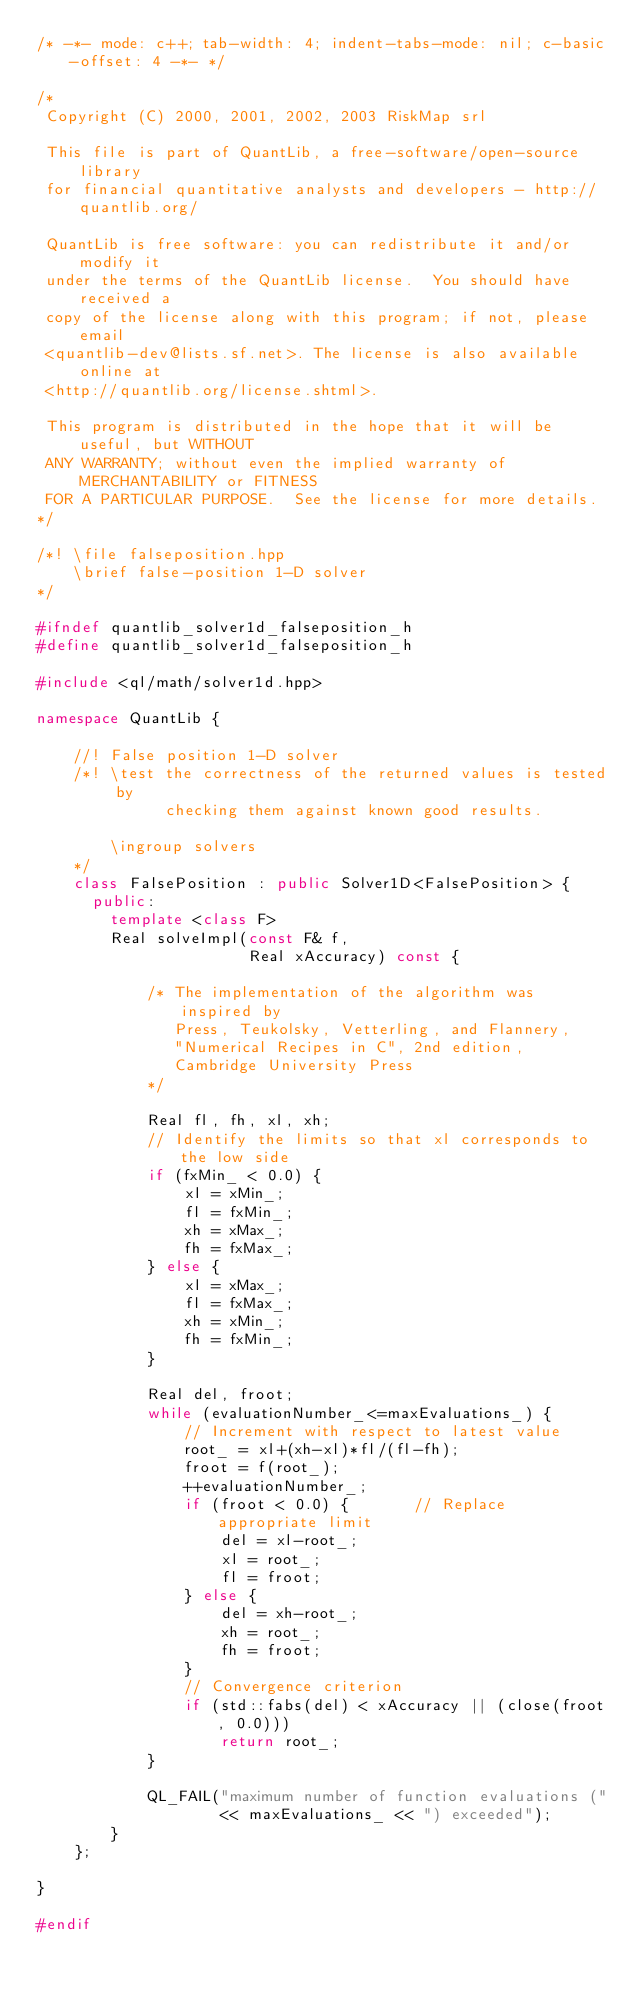<code> <loc_0><loc_0><loc_500><loc_500><_C++_>/* -*- mode: c++; tab-width: 4; indent-tabs-mode: nil; c-basic-offset: 4 -*- */

/*
 Copyright (C) 2000, 2001, 2002, 2003 RiskMap srl

 This file is part of QuantLib, a free-software/open-source library
 for financial quantitative analysts and developers - http://quantlib.org/

 QuantLib is free software: you can redistribute it and/or modify it
 under the terms of the QuantLib license.  You should have received a
 copy of the license along with this program; if not, please email
 <quantlib-dev@lists.sf.net>. The license is also available online at
 <http://quantlib.org/license.shtml>.

 This program is distributed in the hope that it will be useful, but WITHOUT
 ANY WARRANTY; without even the implied warranty of MERCHANTABILITY or FITNESS
 FOR A PARTICULAR PURPOSE.  See the license for more details.
*/

/*! \file falseposition.hpp
    \brief false-position 1-D solver
*/

#ifndef quantlib_solver1d_falseposition_h
#define quantlib_solver1d_falseposition_h

#include <ql/math/solver1d.hpp>

namespace QuantLib {

    //! False position 1-D solver
    /*! \test the correctness of the returned values is tested by
              checking them against known good results.

        \ingroup solvers
    */
    class FalsePosition : public Solver1D<FalsePosition> {
      public:
        template <class F>
        Real solveImpl(const F& f,
                       Real xAccuracy) const {

            /* The implementation of the algorithm was inspired by
               Press, Teukolsky, Vetterling, and Flannery,
               "Numerical Recipes in C", 2nd edition,
               Cambridge University Press
            */

            Real fl, fh, xl, xh;
            // Identify the limits so that xl corresponds to the low side
            if (fxMin_ < 0.0) {
                xl = xMin_;
                fl = fxMin_;
                xh = xMax_;
                fh = fxMax_;
            } else {
                xl = xMax_;
                fl = fxMax_;
                xh = xMin_;
                fh = fxMin_;
            }

            Real del, froot;
            while (evaluationNumber_<=maxEvaluations_) {
                // Increment with respect to latest value
                root_ = xl+(xh-xl)*fl/(fl-fh);
                froot = f(root_);
                ++evaluationNumber_;
                if (froot < 0.0) {       // Replace appropriate limit
                    del = xl-root_;
                    xl = root_;
                    fl = froot;
                } else {
                    del = xh-root_;
                    xh = root_;
                    fh = froot;
                }
                // Convergence criterion
                if (std::fabs(del) < xAccuracy || (close(froot, 0.0)))
                    return root_;
            }

            QL_FAIL("maximum number of function evaluations ("
                    << maxEvaluations_ << ") exceeded");
        }
    };

}

#endif
</code> 